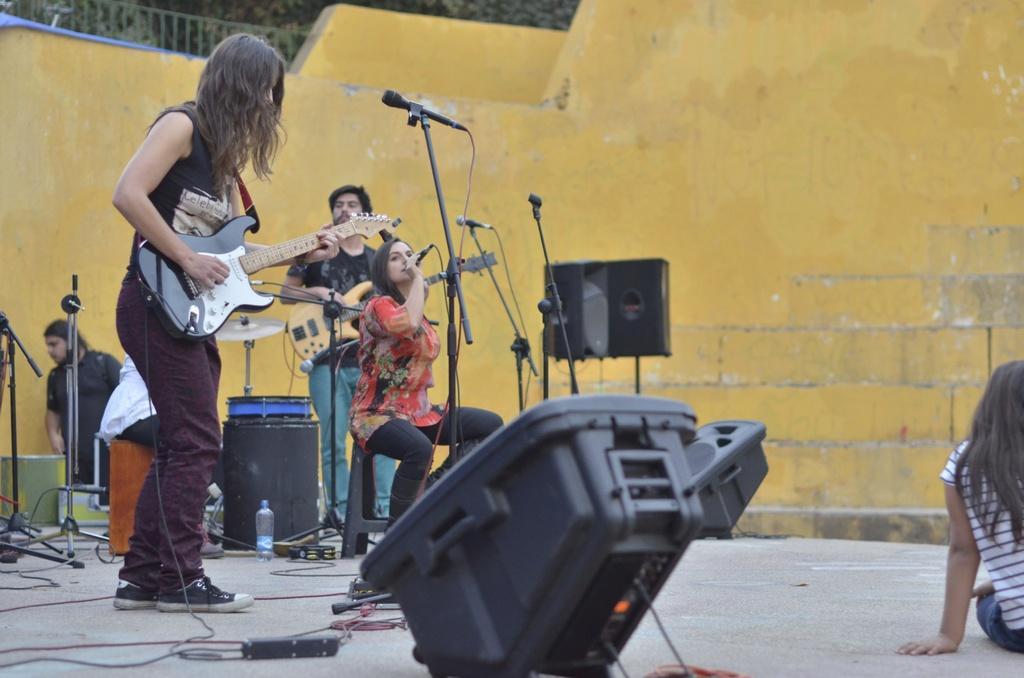Can you describe this image briefly? In this image I can see a woman is standing and holding a guitar. I can also few more people where she is sitting and holding a mic and here a man with guitar. Here I can see few mice and few speakers. I can see one more person. 